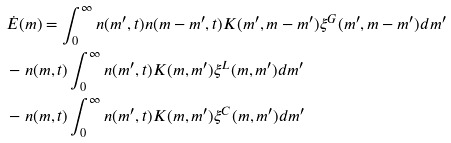Convert formula to latex. <formula><loc_0><loc_0><loc_500><loc_500>& \dot { E } ( m ) = \int ^ { \infty } _ { 0 } n ( m ^ { \prime } , t ) n ( m - m ^ { \prime } , t ) K ( m ^ { \prime } , m - m ^ { \prime } ) \xi ^ { G } ( m ^ { \prime } , m - m ^ { \prime } ) d m ^ { \prime } \\ & - n ( m , t ) \int ^ { \infty } _ { 0 } n ( m ^ { \prime } , t ) K ( m , m ^ { \prime } ) \xi ^ { L } ( m , m ^ { \prime } ) d m ^ { \prime } \\ & - n ( m , t ) \int ^ { \infty } _ { 0 } n ( m ^ { \prime } , t ) K ( m , m ^ { \prime } ) \xi ^ { C } ( m , m ^ { \prime } ) d m ^ { \prime }</formula> 